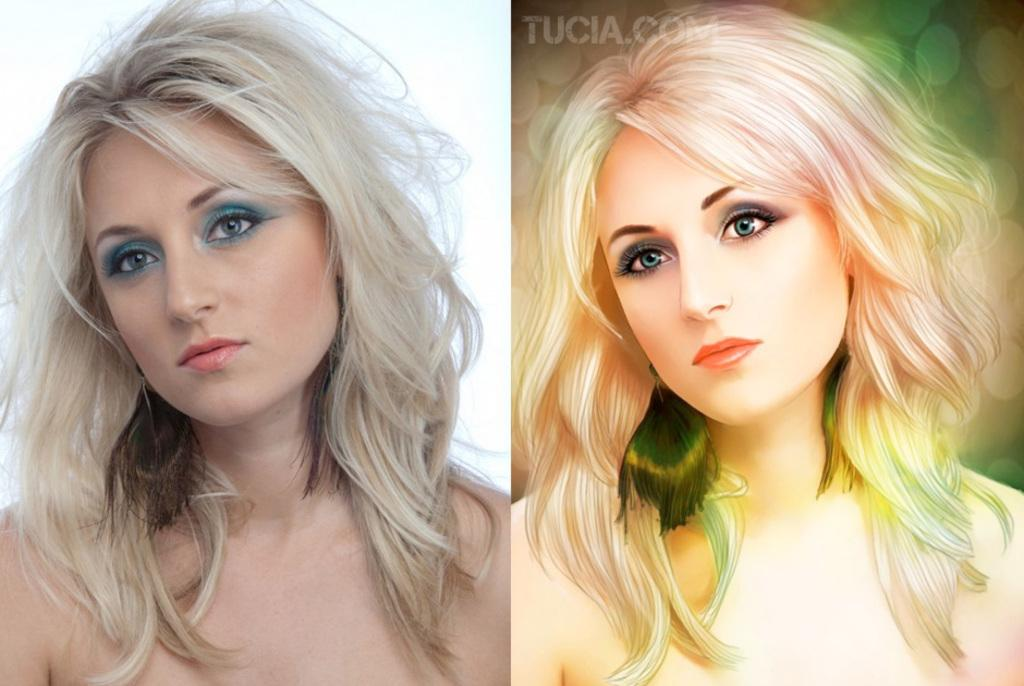Who is present in the image? There is a woman in the image. What is the woman doing in the image? The woman is standing and watching. Is there any additional graphic element in the image? Yes, there is a graphical image in the bottom right corner of the image. Can you see a man ploughing a field in the image? No, there is no man ploughing a field in the image. What type of ear is visible on the woman in the image? There is no ear visible on the woman in the image. 